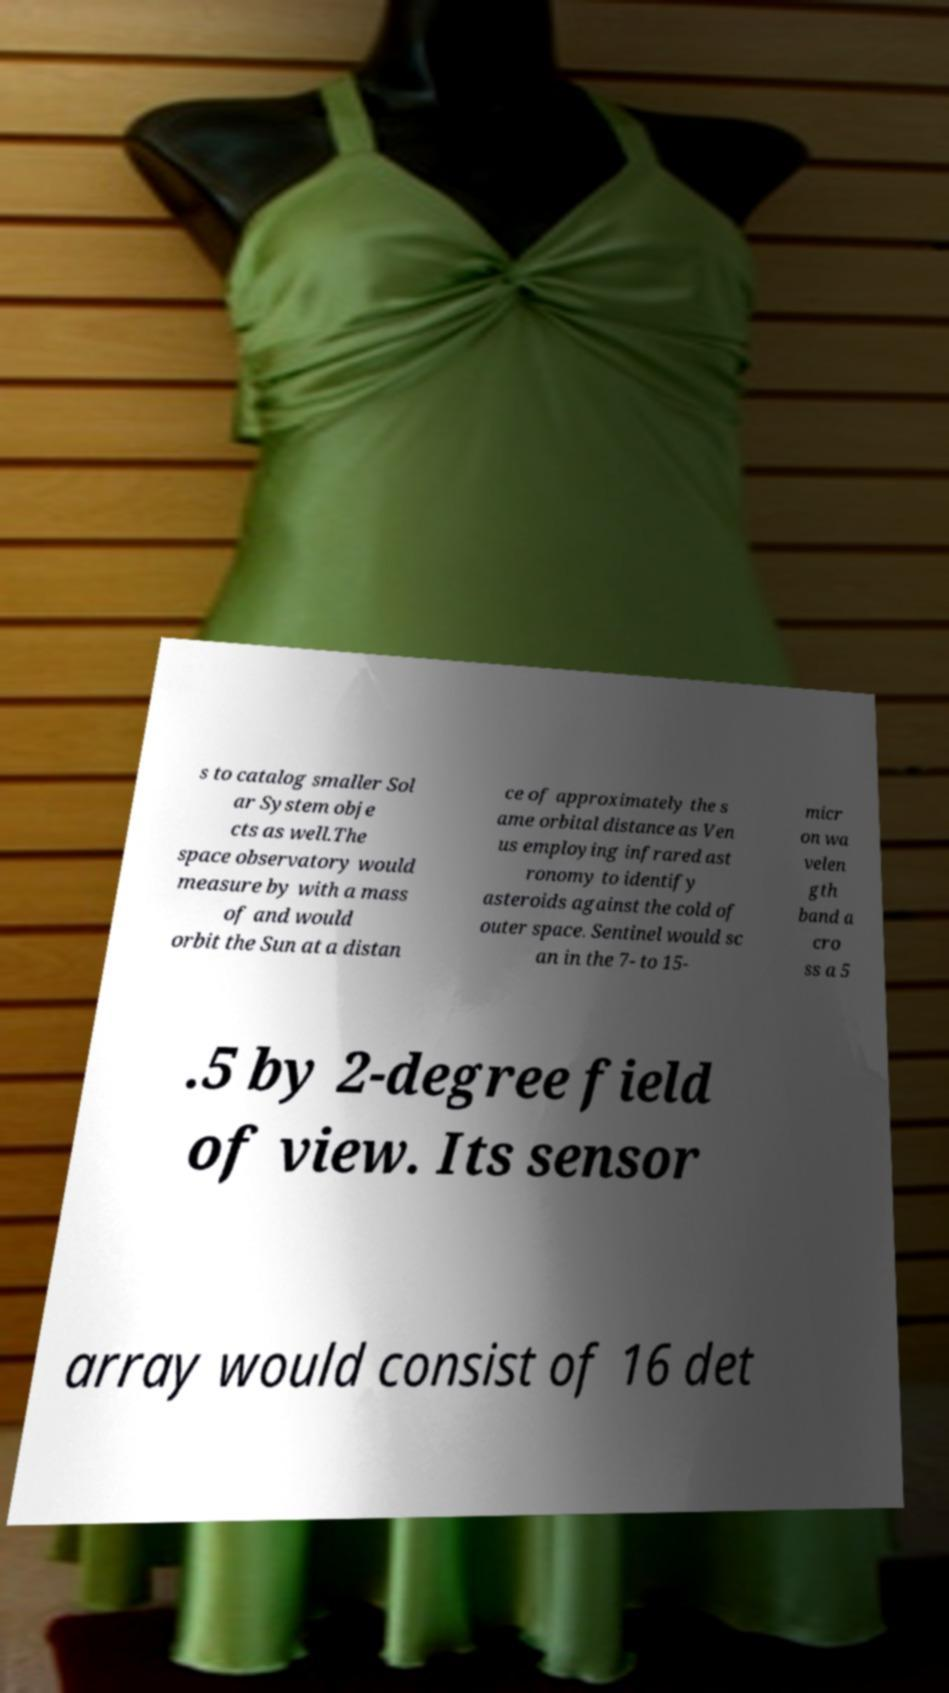Please read and relay the text visible in this image. What does it say? s to catalog smaller Sol ar System obje cts as well.The space observatory would measure by with a mass of and would orbit the Sun at a distan ce of approximately the s ame orbital distance as Ven us employing infrared ast ronomy to identify asteroids against the cold of outer space. Sentinel would sc an in the 7- to 15- micr on wa velen gth band a cro ss a 5 .5 by 2-degree field of view. Its sensor array would consist of 16 det 